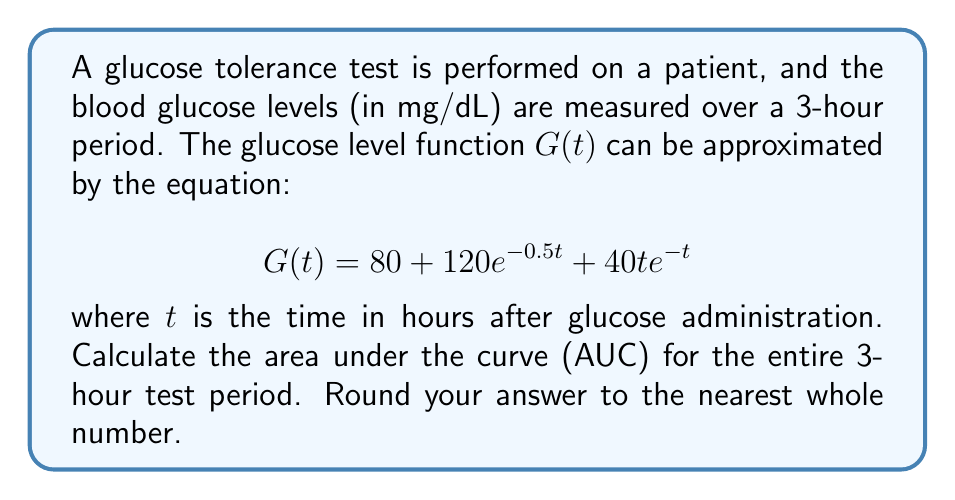Solve this math problem. To find the area under the curve (AUC) for the glucose tolerance test, we need to integrate the glucose level function $G(t)$ from $t=0$ to $t=3$. Let's break this down step-by-step:

1) The integral we need to evaluate is:

   $$\int_0^3 G(t) dt = \int_0^3 (80 + 120e^{-0.5t} + 40t e^{-t}) dt$$

2) Let's integrate each term separately:

   a) $\int_0^3 80 dt = 80t \big|_0^3 = 80(3-0) = 240$

   b) $\int_0^3 120e^{-0.5t} dt = -240e^{-0.5t} \big|_0^3 = -240(e^{-1.5} - 1) \approx 184.90$

   c) For $\int_0^3 40t e^{-t} dt$, we need to use integration by parts:
      Let $u = 40t$ and $dv = e^{-t} dt$
      Then $du = 40 dt$ and $v = -e^{-t}$

      $\int_0^3 40t e^{-t} dt = -40te^{-t} \big|_0^3 + \int_0^3 40e^{-t} dt$
      $= -40(3e^{-3} - 0) - 40e^{-t} \big|_0^3$
      $= -120e^{-3} + 40(1 - e^{-3}) \approx 39.93$

3) Adding all parts together:
   $240 + 184.90 + 39.93 = 464.83$

4) Rounding to the nearest whole number: 465
Answer: 465 mg·h/dL 